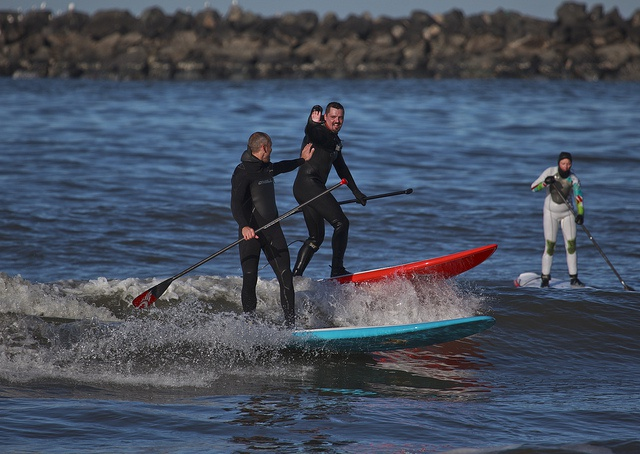Describe the objects in this image and their specific colors. I can see people in gray, black, brown, and maroon tones, people in gray, black, and brown tones, surfboard in gray, black, teal, blue, and darkblue tones, people in gray, darkgray, black, and blue tones, and surfboard in gray, maroon, and brown tones in this image. 